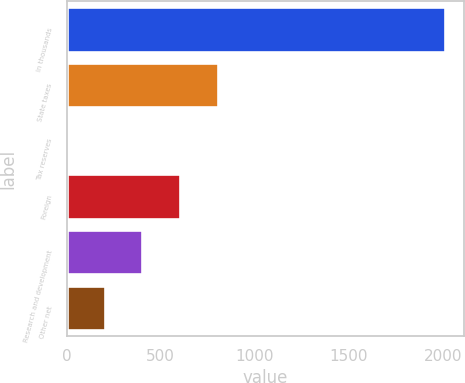<chart> <loc_0><loc_0><loc_500><loc_500><bar_chart><fcel>In thousands<fcel>State taxes<fcel>Tax reserves<fcel>Foreign<fcel>Research and development<fcel>Other net<nl><fcel>2010<fcel>804.12<fcel>0.2<fcel>603.14<fcel>402.16<fcel>201.18<nl></chart> 